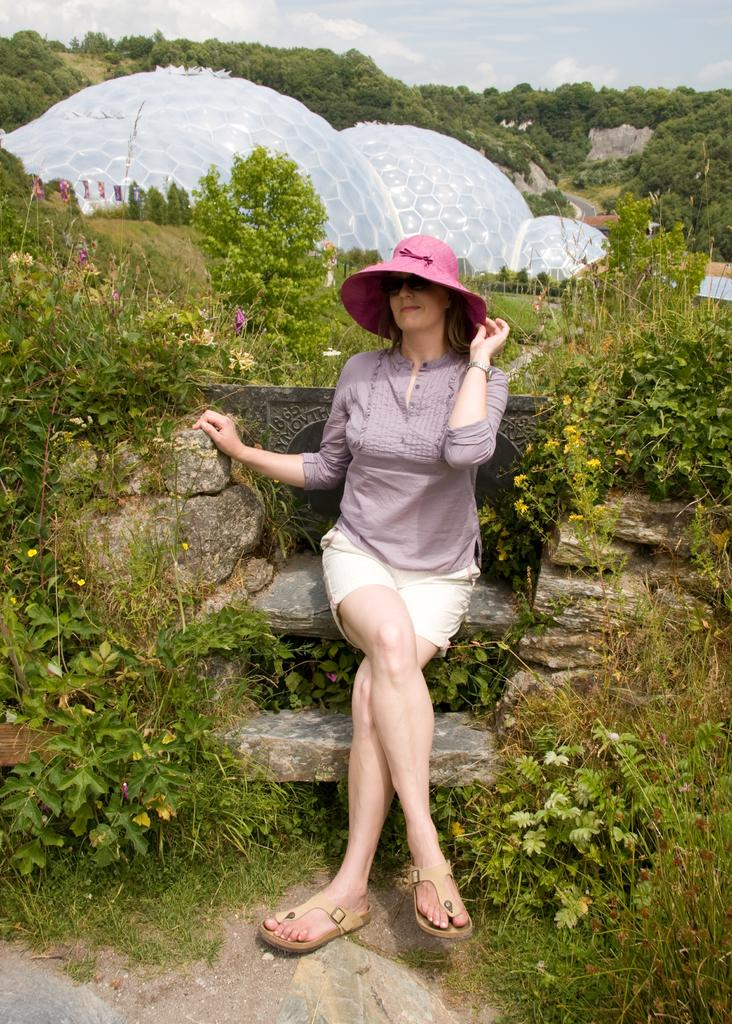Who is the main subject in the image? There is a woman in the image. What is the woman doing in the image? The woman is sitting on a rock. What type of vegetation is present around the woman? There are plants around the woman. What type of ground cover can be seen in the image? There is grass in the image. What can be seen in the background of the image? There are trees in the background of the image. What type of brain is visible in the image? There is no brain present in the image. Is there a beggar asking for money in the image? There is no beggar present in the image. 